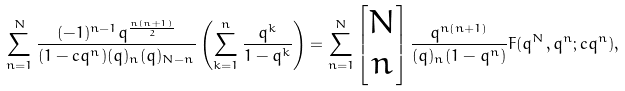<formula> <loc_0><loc_0><loc_500><loc_500>\sum _ { n = 1 } ^ { N } \frac { ( - 1 ) ^ { n - 1 } q ^ { \frac { n ( n + 1 ) } { 2 } } } { ( 1 - c q ^ { n } ) ( q ) _ { n } ( q ) _ { N - n } } \left ( \sum _ { k = 1 } ^ { n } \frac { q ^ { k } } { 1 - q ^ { k } } \right ) = \sum _ { n = 1 } ^ { N } \left [ \begin{matrix} N \\ n \end{matrix} \right ] \frac { q ^ { n ( n + 1 ) } } { ( q ) _ { n } ( 1 - q ^ { n } ) } F ( q ^ { N } , q ^ { n } ; c q ^ { n } ) ,</formula> 